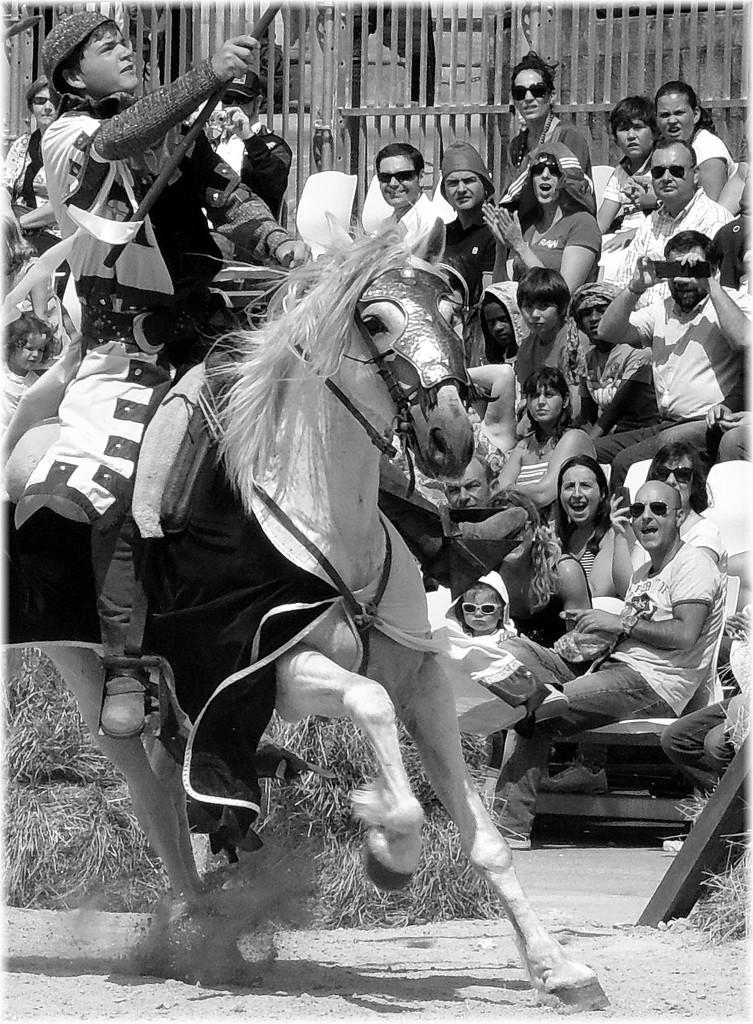What is the person on the horse doing in the image? The person is sitting on a horse. What object is the person holding? The person is holding a rod. Are there any other people visible in the image? Yes, there are audience members sitting beside the person on the horse. What verse is the person reciting while sitting on the horse? There is no indication in the image that the person is reciting a verse. 